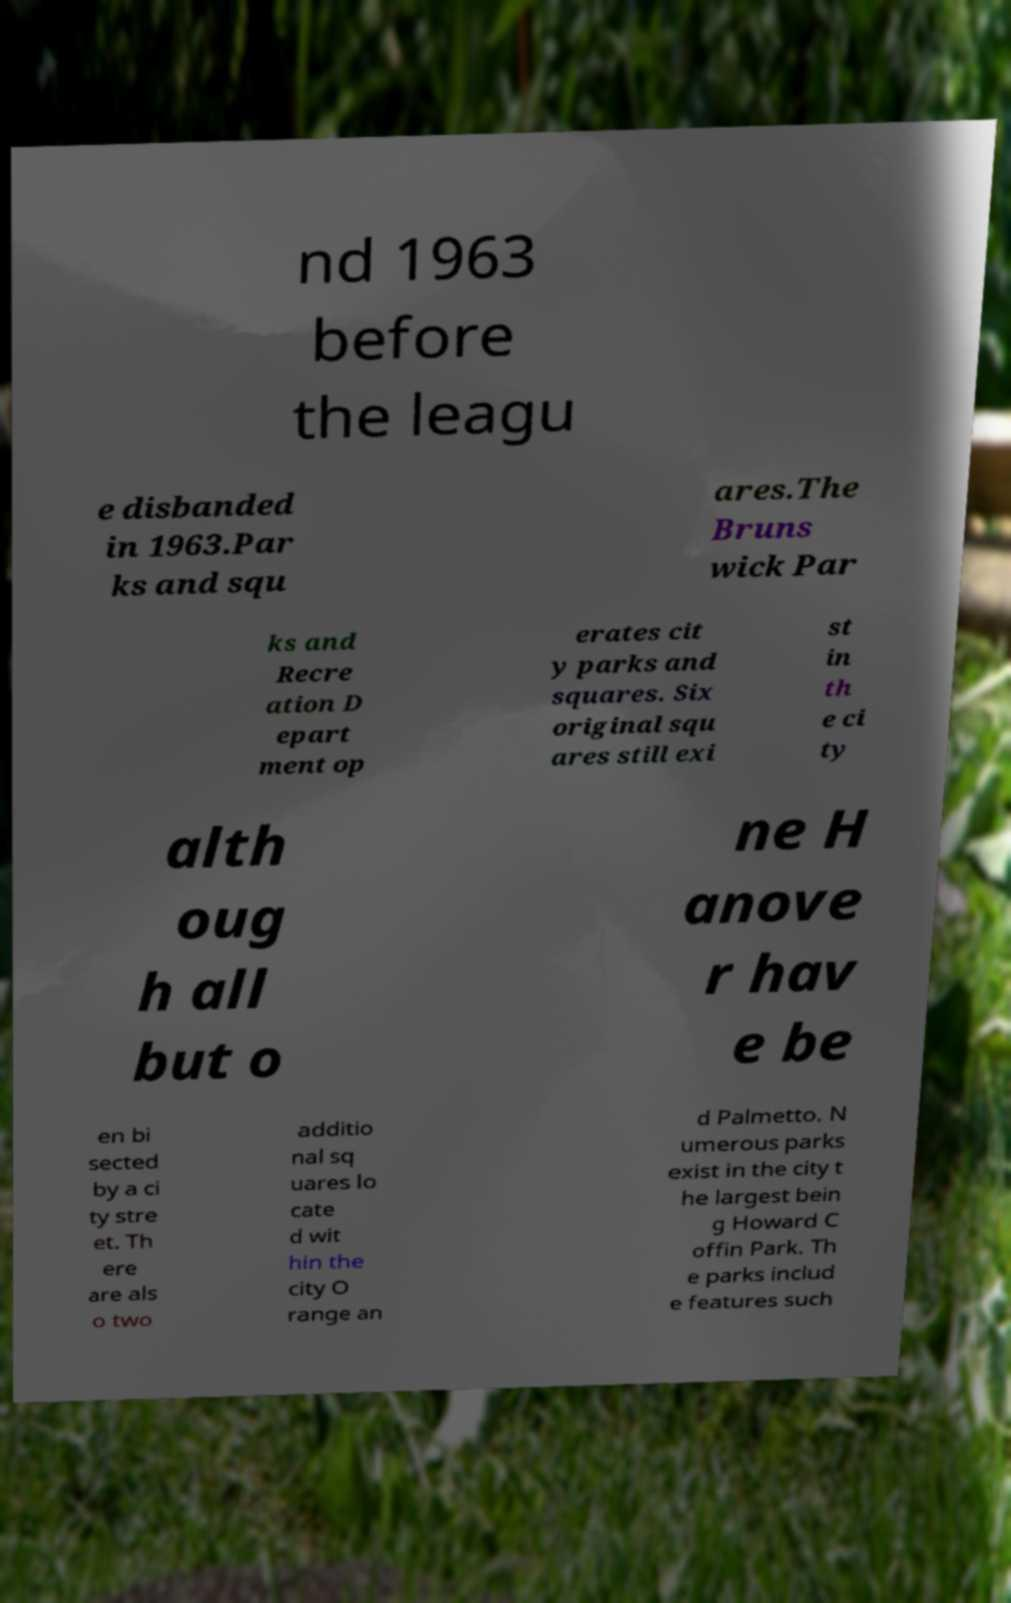Please read and relay the text visible in this image. What does it say? nd 1963 before the leagu e disbanded in 1963.Par ks and squ ares.The Bruns wick Par ks and Recre ation D epart ment op erates cit y parks and squares. Six original squ ares still exi st in th e ci ty alth oug h all but o ne H anove r hav e be en bi sected by a ci ty stre et. Th ere are als o two additio nal sq uares lo cate d wit hin the city O range an d Palmetto. N umerous parks exist in the city t he largest bein g Howard C offin Park. Th e parks includ e features such 